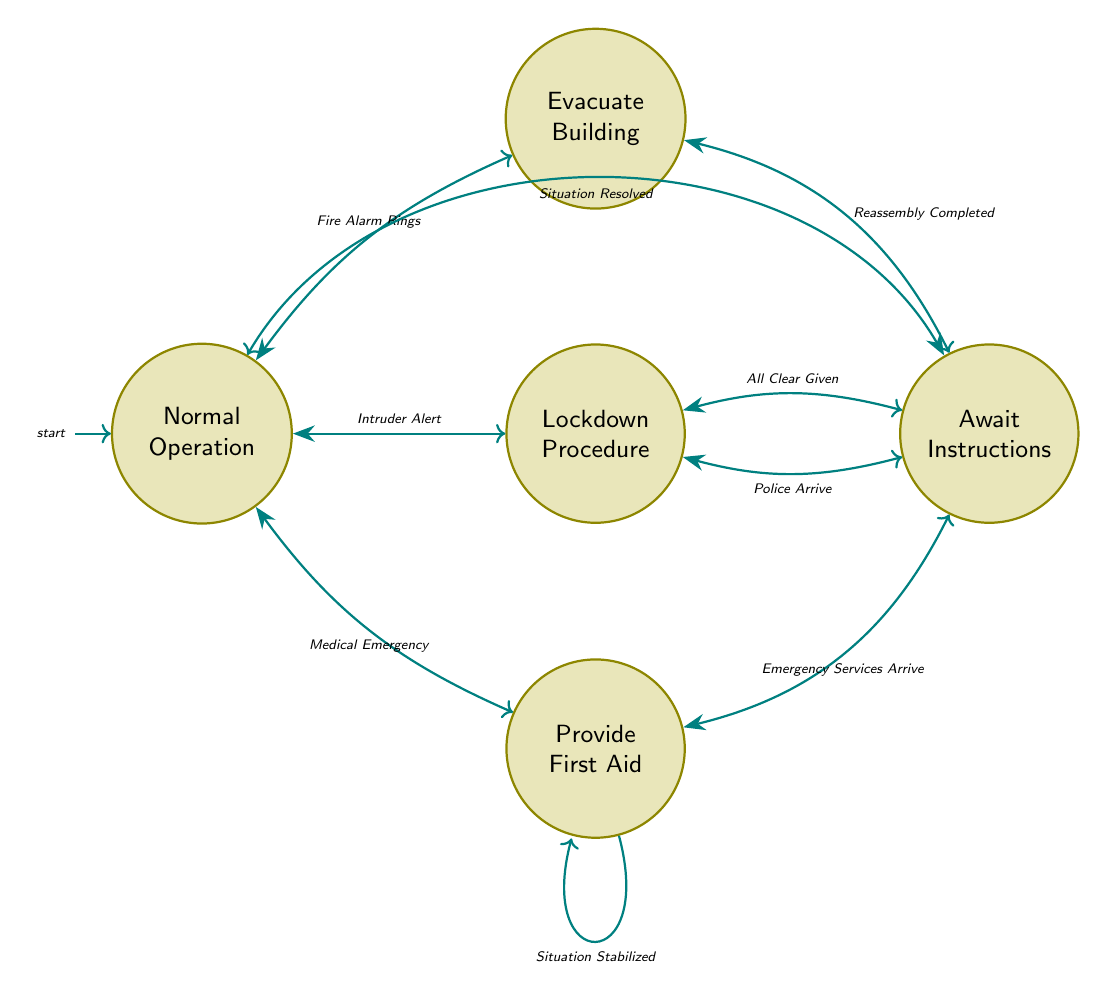What is the initial state of the diagram? The initial state is labeled in the diagram as the starting point of the finite state machine, which is depicted with an incoming arrow. The arrow indicates that this is where the process begins, which corresponds to "Normal Operation".
Answer: Normal Operation How many states are there in total? By reviewing the diagram, we can count the nodes representing different states. There are five distinct states shown: Normal Operation, Evacuate Building, Provide First Aid, Lockdown Procedure, and Await Instructions.
Answer: 5 What transition occurs after a Medical Emergency? Looking at the "Normal Operation" state, we see a transition labeled "Medical Emergency" that leads directly to another state, which in this case is "Provide First Aid".
Answer: Provide First Aid What state do you enter after Emergency Services Arrive? Starting from "Provide First Aid", the transition "Emergency Services Arrive" leads to the "Await Instructions" state. Hence, that is the state reached after this event.
Answer: Await Instructions How does the process exist from the Await Instructions state? The "Await Instructions" state shows a transition labeled "Situation Resolved" that leads back to the state "Normal Operation". This indicates the exit from Await Instructions involves this event.
Answer: Normal Operation What happens immediately after the Fire Alarm Rings? The transition from the "Normal Operation" state when a "Fire Alarm Rings" occurs is directed to the next state, which is "Evacuate Building". This indicates the immediate response to this alarm.
Answer: Evacuate Building Which state follows the Lockdown Procedure if an All Clear is given? Observing the transitions from the "Lockdown Procedure", the event labeled "All Clear Given" leads directly to the "Await Instructions" state. Therefore, that is the following state.
Answer: Await Instructions How many transitions lead to the Await Instructions state? If we examine the diagram, we can see multiple transitions leading into the "Await Instructions" state: from "Evacuate Building", "Provide First Aid", and "Lockdown Procedure". These make for three distinct transitions that lead into this state.
Answer: 3 What is the description of the Normal Operation state? The diagram describes the "Normal Operation" state as the one where class is running normally, indicating that it is the initial and typical functioning state.
Answer: Class is running normally 